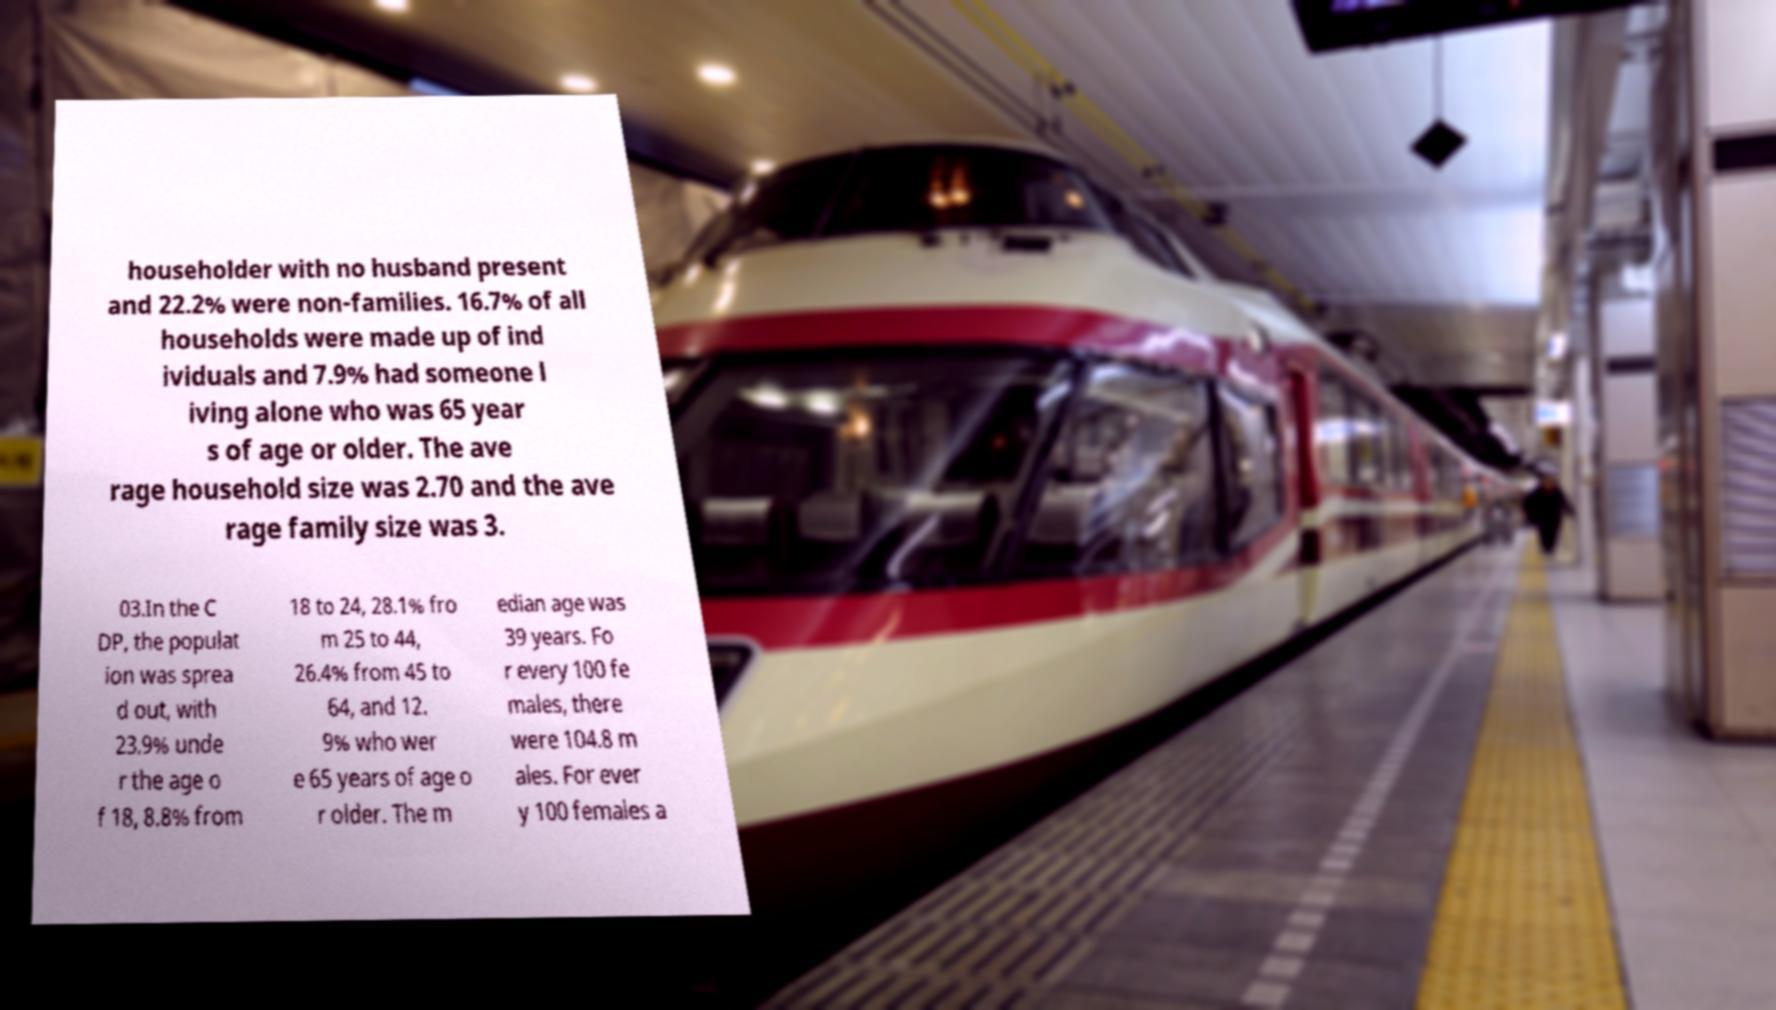Could you assist in decoding the text presented in this image and type it out clearly? householder with no husband present and 22.2% were non-families. 16.7% of all households were made up of ind ividuals and 7.9% had someone l iving alone who was 65 year s of age or older. The ave rage household size was 2.70 and the ave rage family size was 3. 03.In the C DP, the populat ion was sprea d out, with 23.9% unde r the age o f 18, 8.8% from 18 to 24, 28.1% fro m 25 to 44, 26.4% from 45 to 64, and 12. 9% who wer e 65 years of age o r older. The m edian age was 39 years. Fo r every 100 fe males, there were 104.8 m ales. For ever y 100 females a 